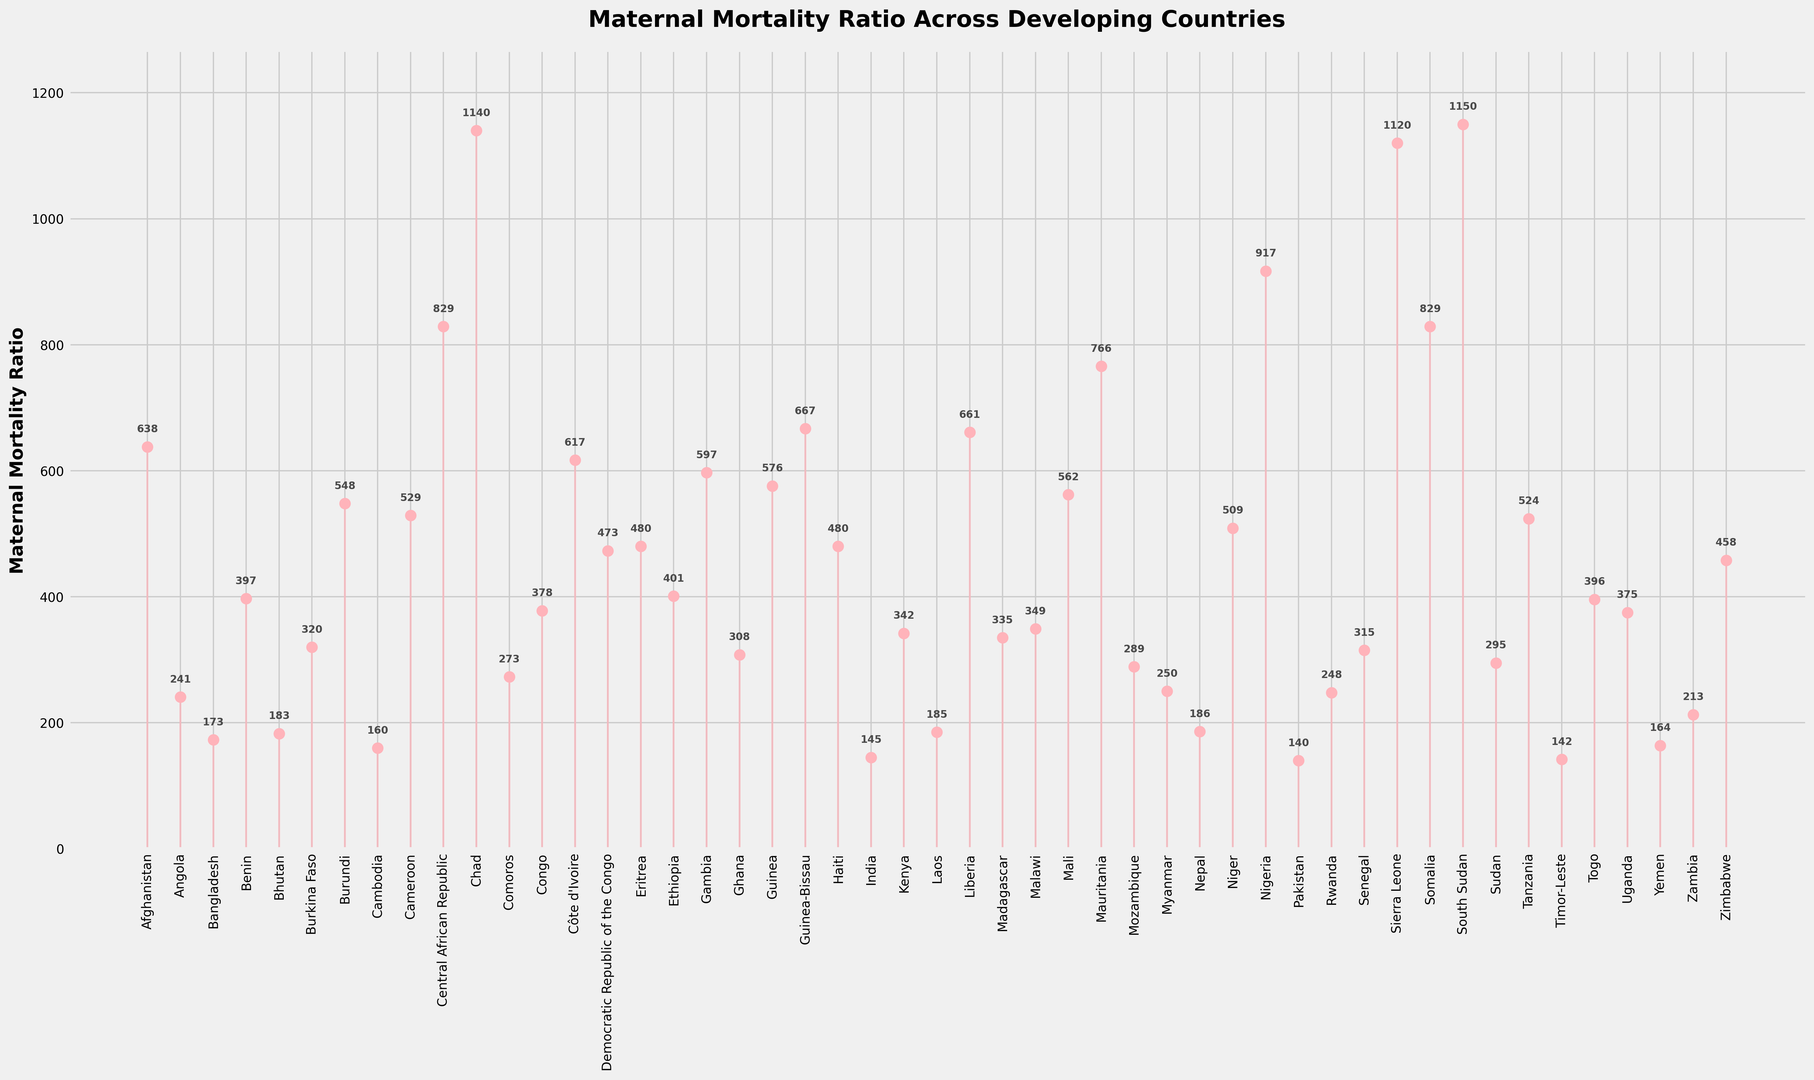Which country has the highest Maternal Mortality Ratio? The highest point in the stem plot corresponds to the country with the highest Maternal Mortality Ratio. The highest point is for South Sudan with a value of 1150.
Answer: South Sudan Which country has the lowest Maternal Mortality Ratio? The lowest point in the stem plot corresponds to the country with the lowest Maternal Mortality Ratio. The lowest point is for Pakistan with a value of 140.
Answer: Pakistan What is the Maternal Mortality Ratio difference between Nigeria and Pakistan? The Maternal Mortality Ratios for Nigeria and Pakistan are 917 and 140, respectively. The difference is 917 - 140 = 777.
Answer: 777 Which country has a higher Maternal Mortality Ratio: Afghanistan or Zambia? By comparing the heights of the points for Afghanistan and Zambia, it is evident that Afghanistan (638) has a higher Maternal Mortality Ratio than Zambia (213).
Answer: Afghanistan How many countries have a Maternal Mortality Ratio above 500? By counting the points above the 500 mark on the y-axis, there are 12 countries with a Maternal Mortality Ratio above 500 (Afghanistan, Burundi, Central African Republic, Chad, Côte d'Ivoire, Gambia, Guinea, Guinea-Bissau, Liberia, Mali, Sierra Leone, South Sudan).
Answer: 12 What is the average Maternal Mortality Ratio for the five countries with the lowest values? The five countries with the lowest Maternal Mortality Ratios are Pakistan (140), India (145), Timor-Leste (142), Cambodia (160), and Yemen (164). The average is (140 + 145 + 142 + 160 + 164) / 5 = 150.2.
Answer: 150.2 How much higher is the Maternal Mortality Ratio in Chad compared to India? The Maternal Mortality Ratio for Chad is 1140 and for India is 145. The difference is 1140 - 145 = 995.
Answer: 995 What is the median Maternal Mortality Ratio of all the countries listed? To find the median, list all Maternal Mortality Ratios in ascending order and locate the middle value. With 50 data points, the median is the average of the 25th and 26th values: (315 (Senegal) + 320 (Burkina Faso)) / 2 = 317.5.
Answer: 317.5 